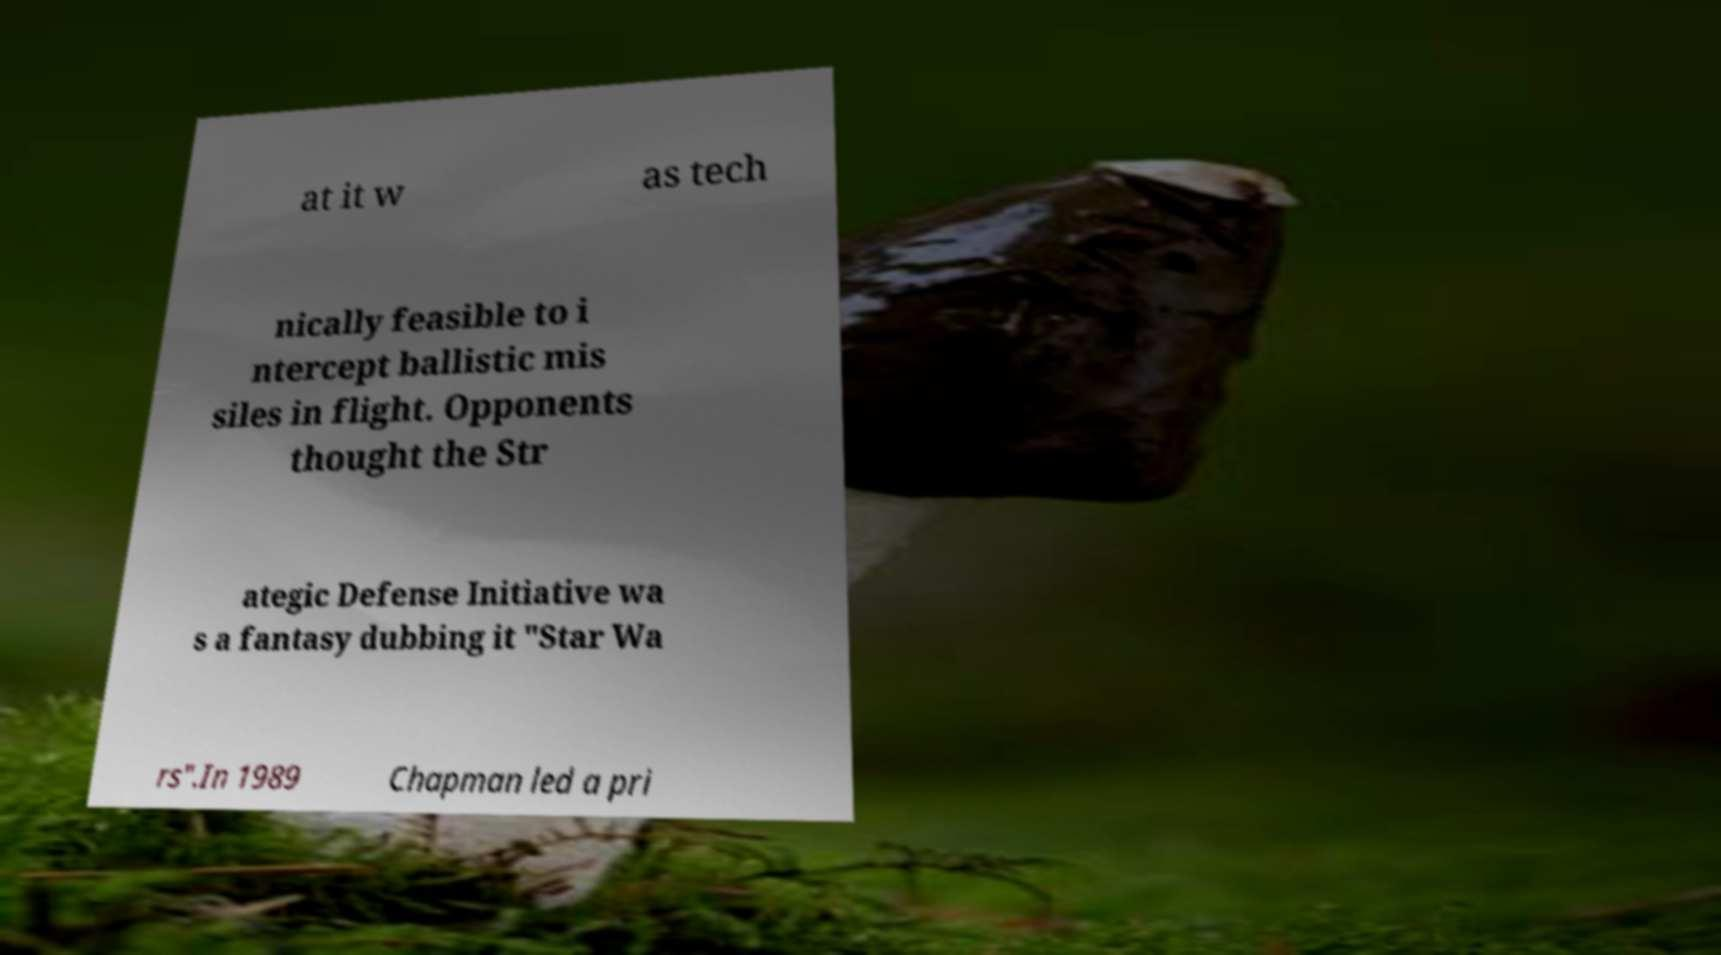Could you extract and type out the text from this image? at it w as tech nically feasible to i ntercept ballistic mis siles in flight. Opponents thought the Str ategic Defense Initiative wa s a fantasy dubbing it "Star Wa rs".In 1989 Chapman led a pri 